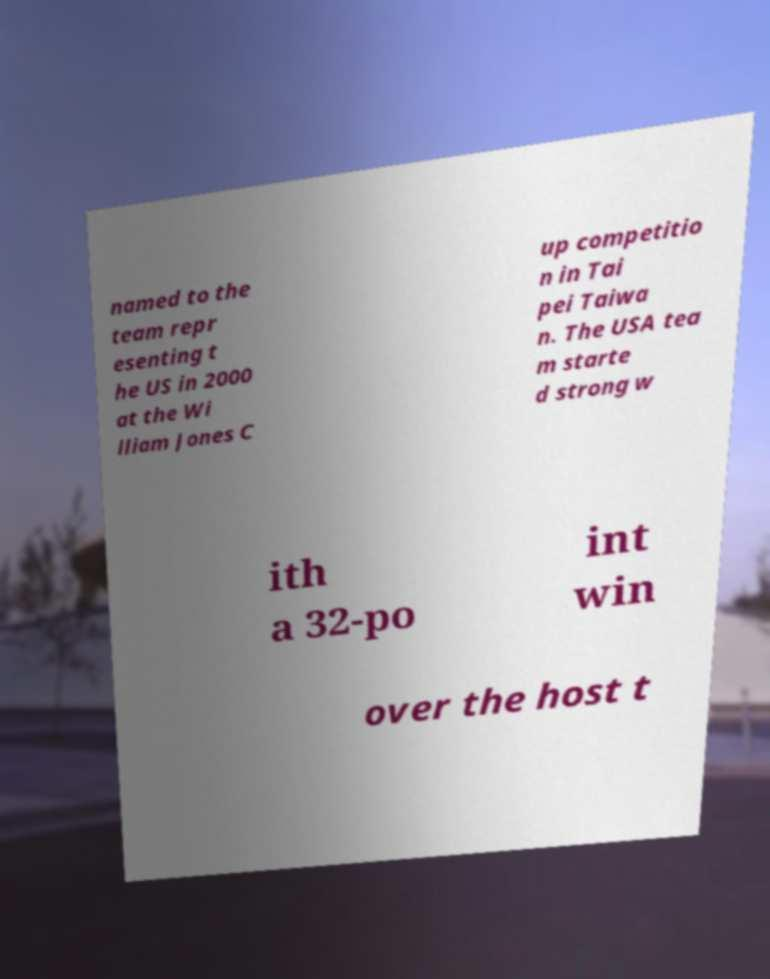Can you accurately transcribe the text from the provided image for me? named to the team repr esenting t he US in 2000 at the Wi lliam Jones C up competitio n in Tai pei Taiwa n. The USA tea m starte d strong w ith a 32-po int win over the host t 